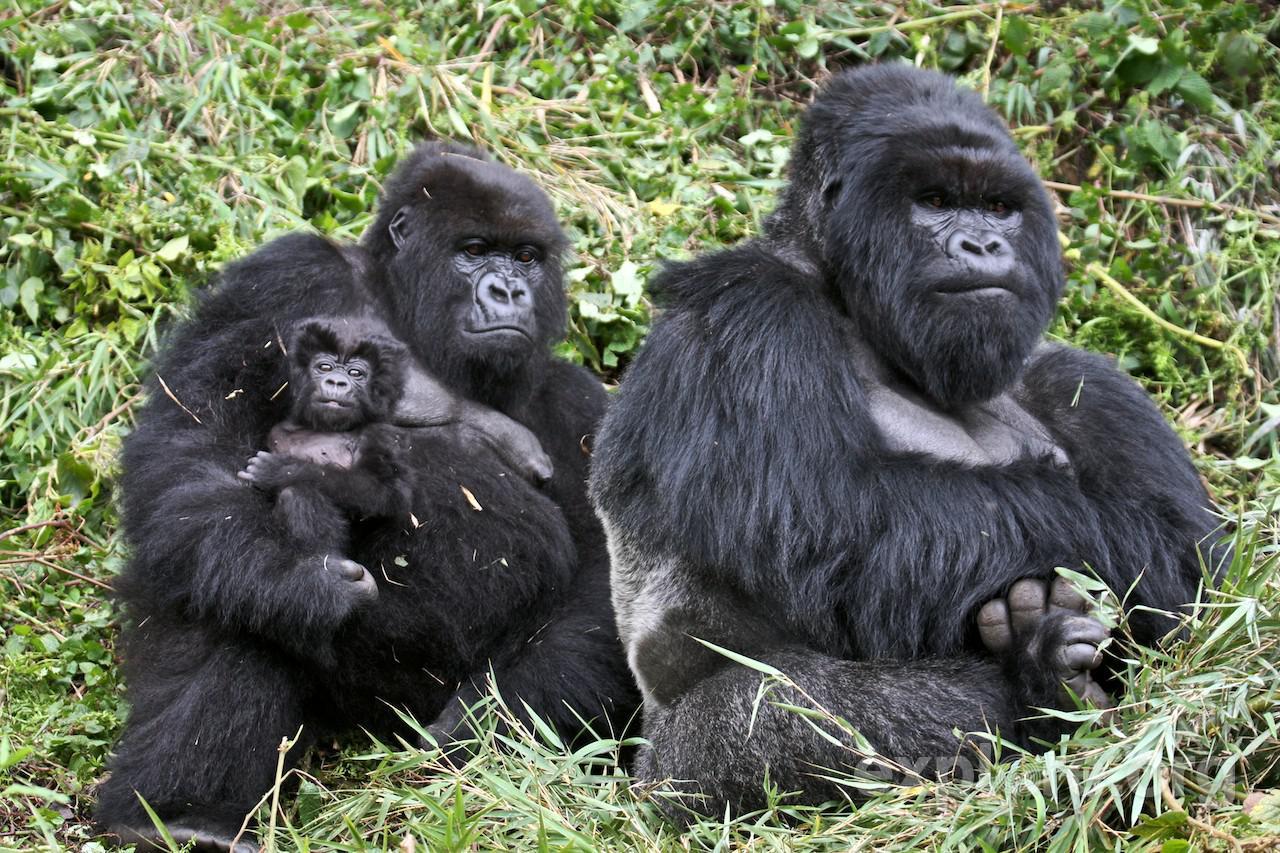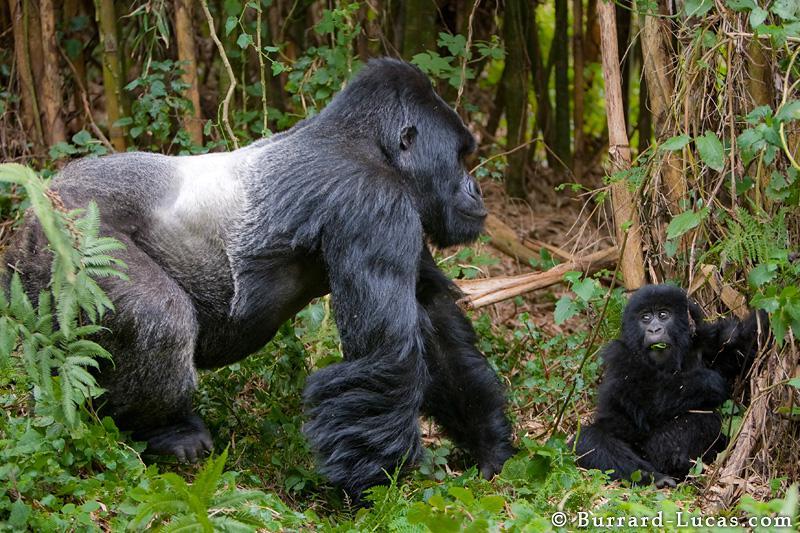The first image is the image on the left, the second image is the image on the right. Assess this claim about the two images: "Each image features exactly one gorilla, a fierce-looking adult male.". Correct or not? Answer yes or no. No. The first image is the image on the left, the second image is the image on the right. Given the left and right images, does the statement "At least one of the images show a baby gorilla" hold true? Answer yes or no. Yes. 